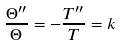<formula> <loc_0><loc_0><loc_500><loc_500>\frac { \Theta ^ { \prime \prime } } { \Theta } = - \frac { T ^ { \prime \prime } } { T } = k \\</formula> 